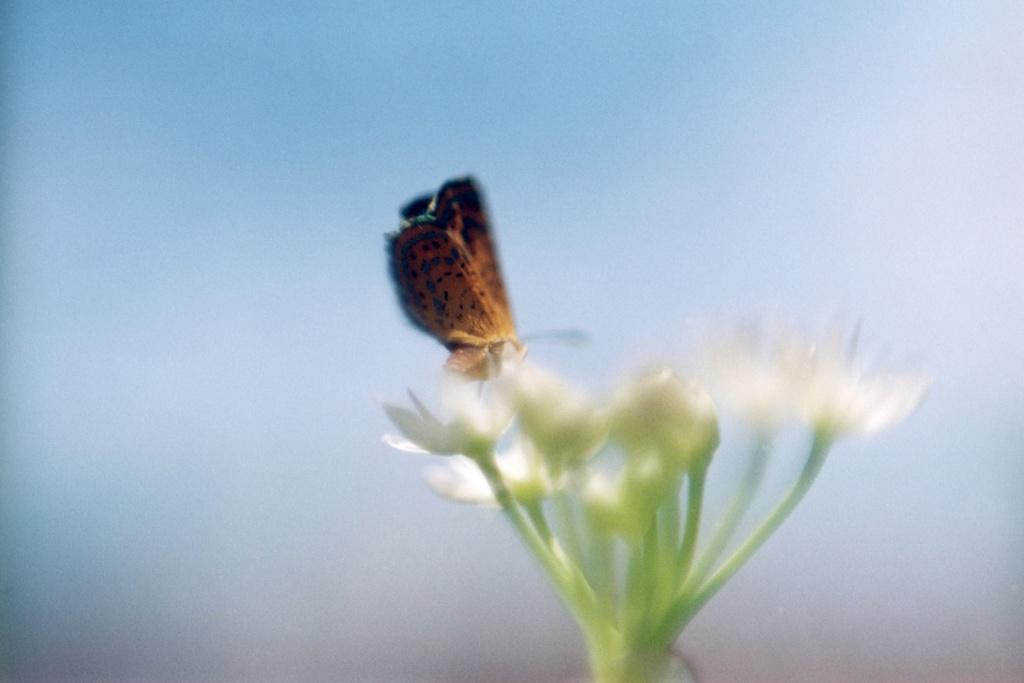What is the main subject of the image? There is a butterfly in the image. Where is the butterfly located in the image? The butterfly is on a flower. What type of cheese is the butterfly using as a quill to write on the celery in the image? There is no cheese, quill, or celery present in the image; it only features a butterfly on a flower. 